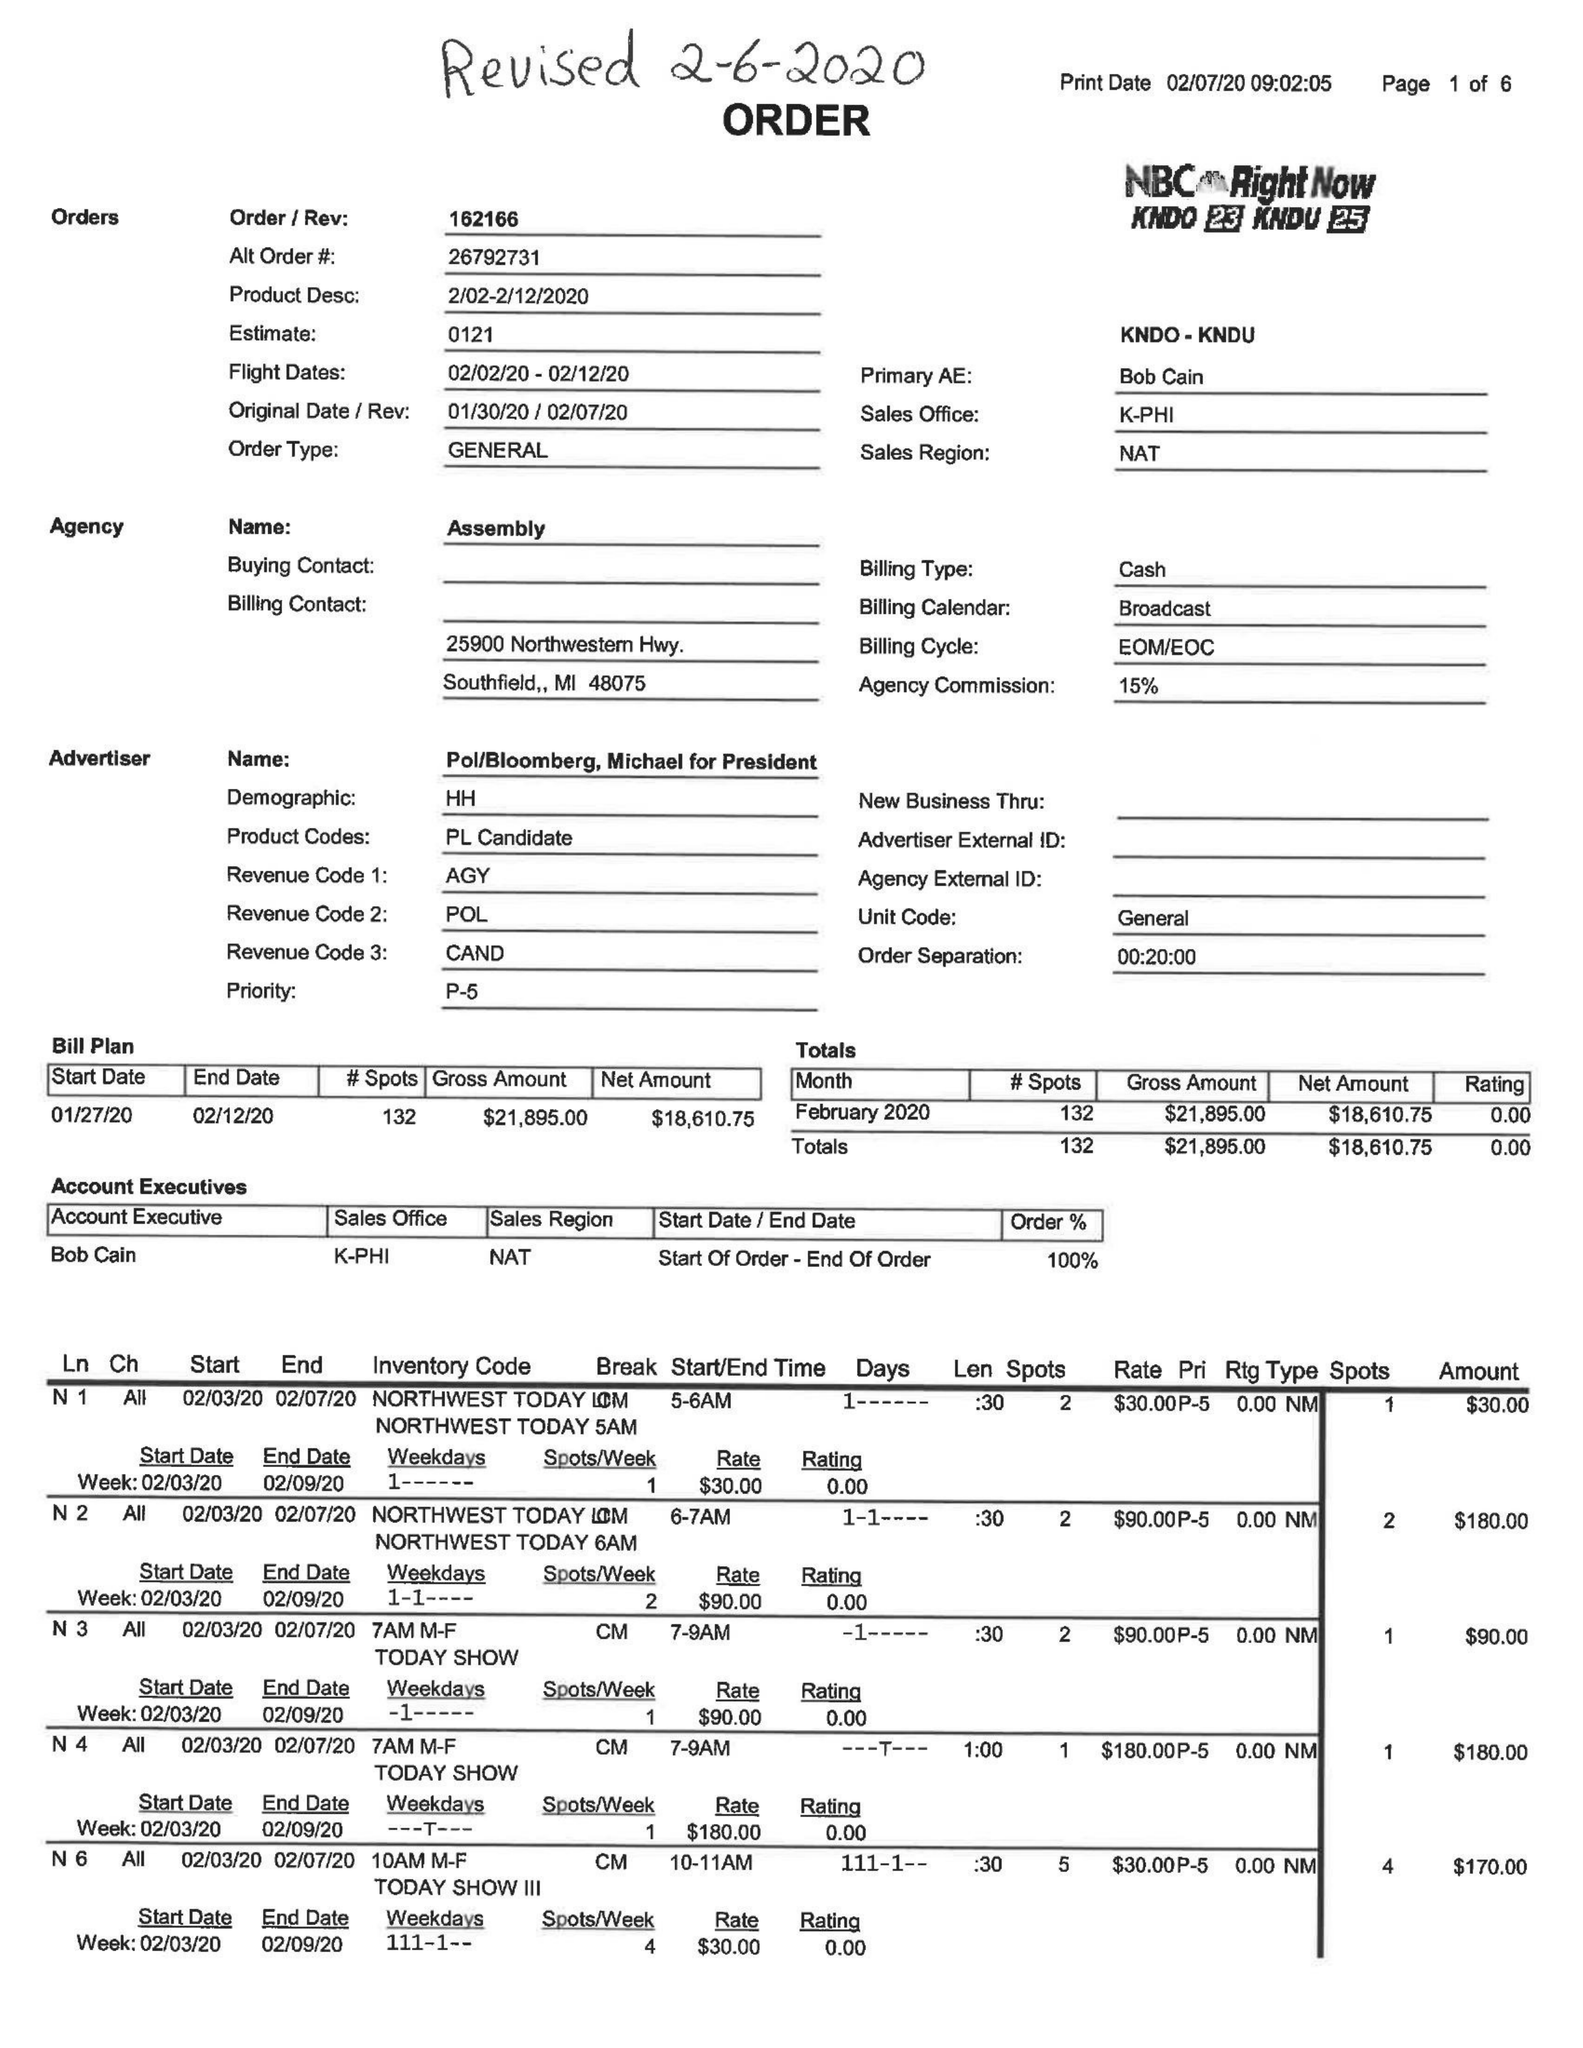What is the value for the advertiser?
Answer the question using a single word or phrase. POL/BLOOMBERG,MICHAELFORPRESIDENT 